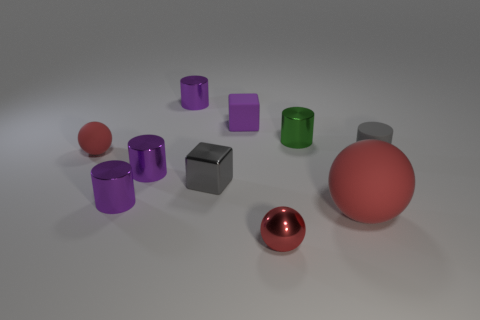Subtract all red balls. How many were subtracted if there are1red balls left? 2 Subtract all purple blocks. How many purple cylinders are left? 3 Subtract all green cylinders. How many cylinders are left? 4 Subtract all gray cylinders. How many cylinders are left? 4 Subtract all blue cylinders. Subtract all blue cubes. How many cylinders are left? 5 Subtract all balls. How many objects are left? 7 Subtract 1 gray cubes. How many objects are left? 9 Subtract all big green matte cylinders. Subtract all metallic spheres. How many objects are left? 9 Add 7 green cylinders. How many green cylinders are left? 8 Add 9 purple rubber cubes. How many purple rubber cubes exist? 10 